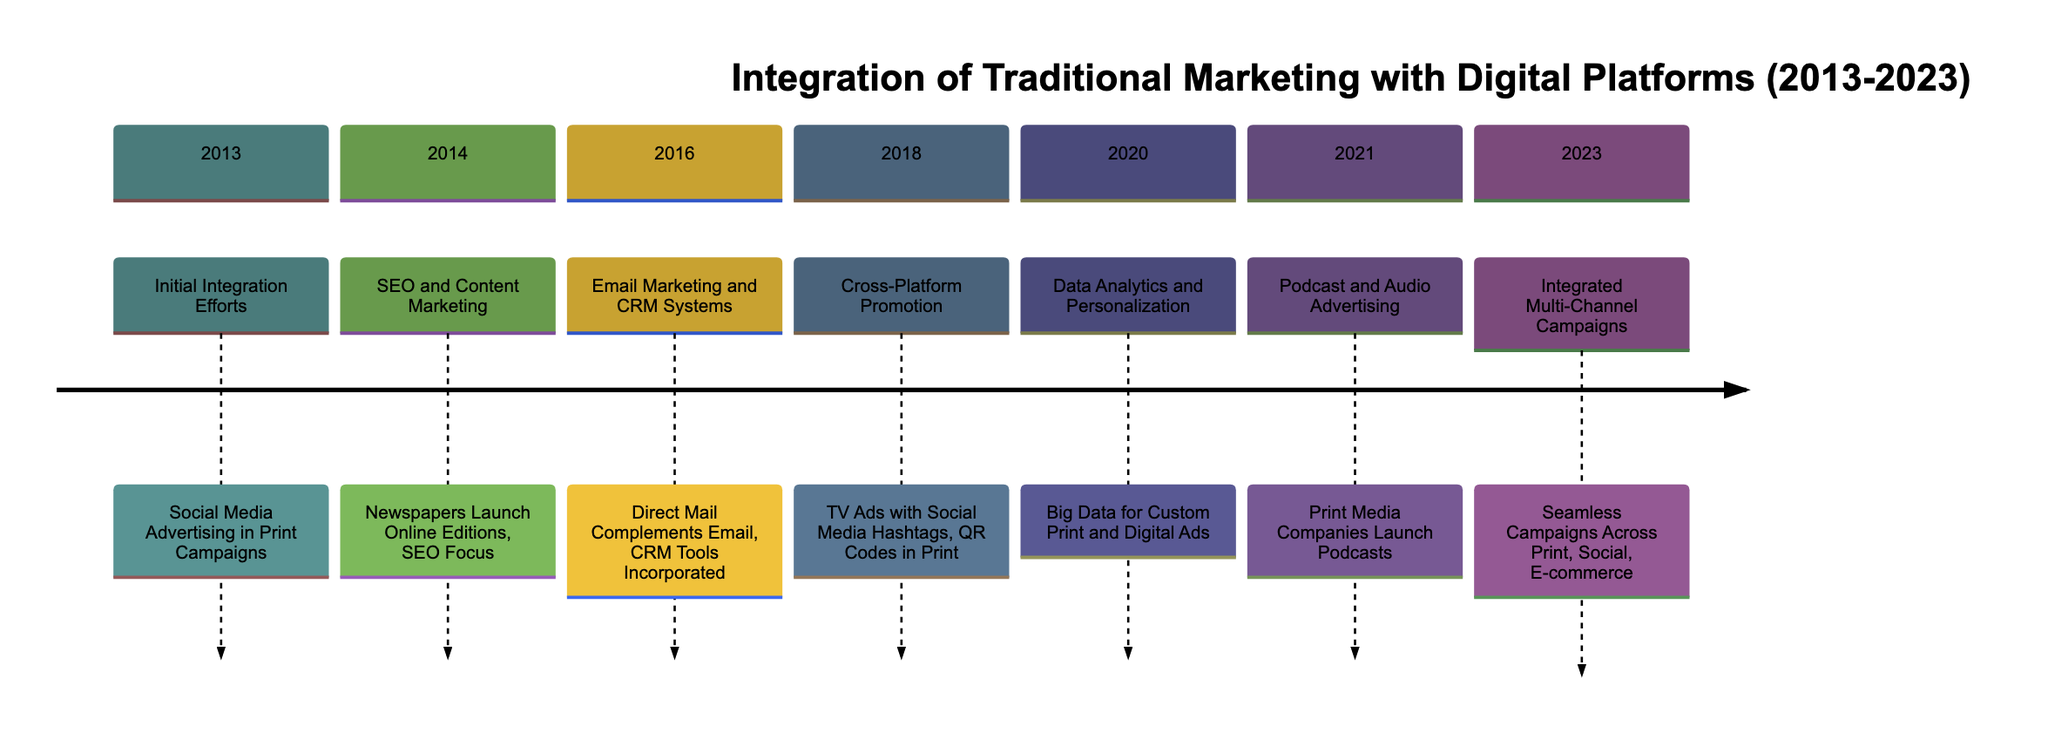What was introduced in 2013? The diagram states that in 2013, the focus was on initial integration efforts, specifically social media advertising in print campaigns. This is the only activity mentioned for that year.
Answer: Social Media Advertising in Print Campaigns How many sections are there in the timeline? By analyzing the diagram, we can count the number of distinct sections listed, which are from 2013 to 2023. This totals to 7 sections.
Answer: 7 What was emphasized in 2016? The diagram indicates that in 2016, the focus was on email marketing and CRM systems, describing how direct mail complements email and CRM tools are incorporated.
Answer: Email Marketing and CRM Systems What major change occurred between 2020 and 2021? The transition from 2020 to 2021 in the timeline highlights a shift in focus from data analytics and personalization to the introduction of podcast and audio advertising by print media companies. This signifies a growing reliance on audio content.
Answer: Introduction of Podcast and Audio Advertising What does the timeline suggest about the trend in integrated marketing by 2023? The final section of the timeline for 2023 shows a culmination of efforts expressed as integrated multi-channel campaigns across various media, including print, social media, and e-commerce. This indicates a holistic approach to marketing strategies.
Answer: Integrated Multi-Channel Campaigns What two platforms were used for promotion in 2018? In 2018, the diagram notes that the promotion methods included TV ads combined with social media hashtags and QR codes in print materials, linking traditional and digital advertising techniques.
Answer: TV Ads and Social Media Hashtags Which year saw the launch of online editions by newspapers? The diagram specifically states that in 2014, newspapers launched online editions while focusing on search engine optimization (SEO). This marked a significant step in integrating digital aspects with traditional methods.
Answer: 2014 What does the integration of data analytics in 2020 imply about marketing strategies? The inclusion of data analytics and personalization in 2020 suggests that marketing strategies started to rely heavily on data to create customized print and digital advertisements, indicating a shift towards a more data-driven approach.
Answer: Data-Driven Approach 